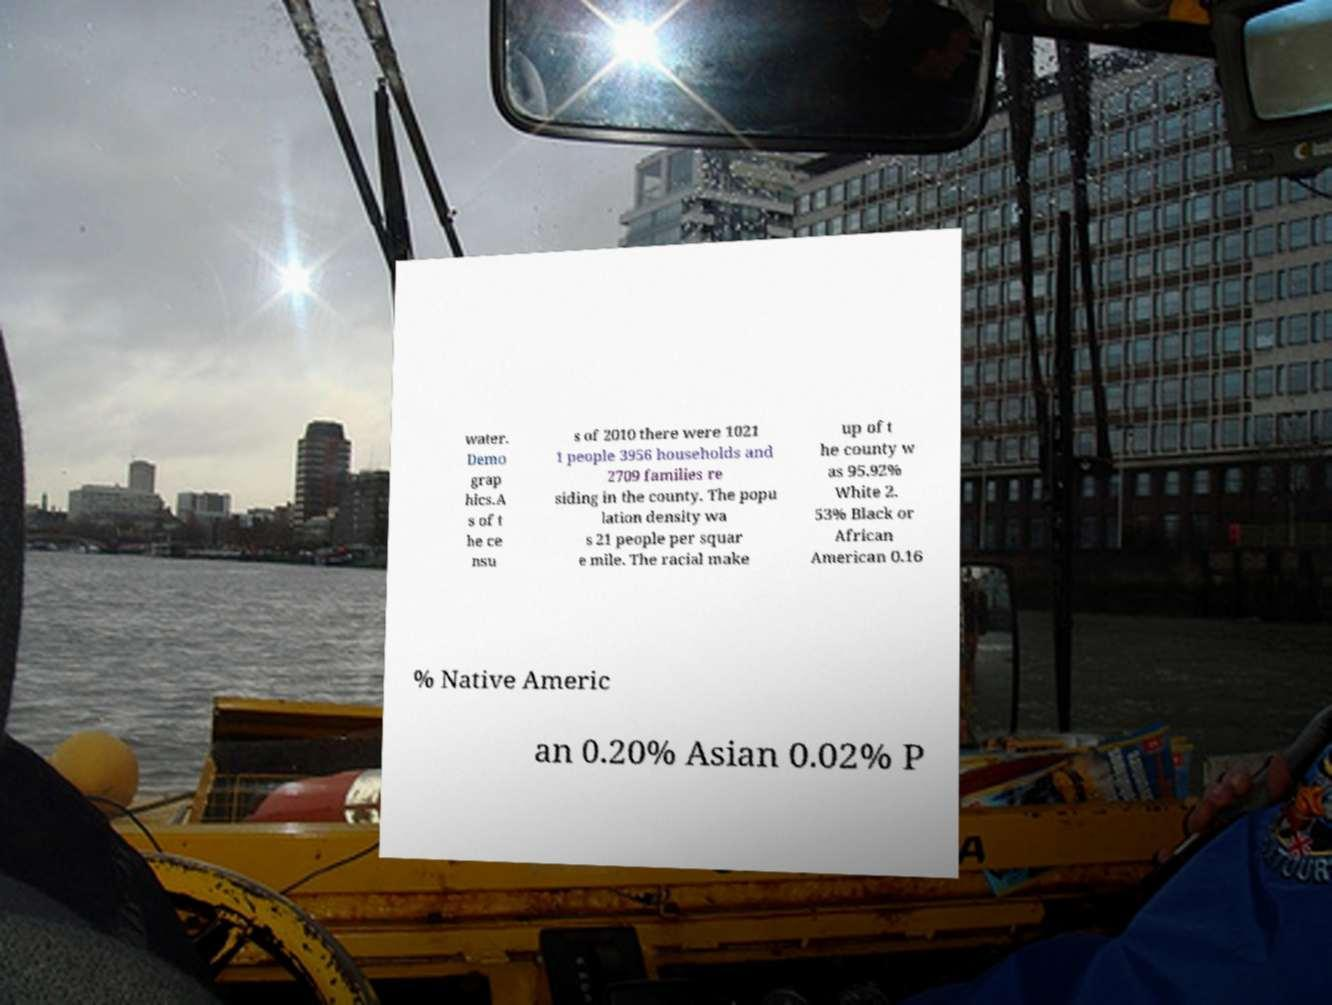Could you extract and type out the text from this image? water. Demo grap hics.A s of t he ce nsu s of 2010 there were 1021 1 people 3956 households and 2709 families re siding in the county. The popu lation density wa s 21 people per squar e mile. The racial make up of t he county w as 95.92% White 2. 53% Black or African American 0.16 % Native Americ an 0.20% Asian 0.02% P 